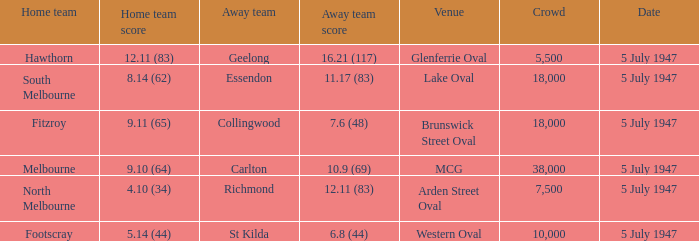What guest team played against footscray as the domestic team? St Kilda. 